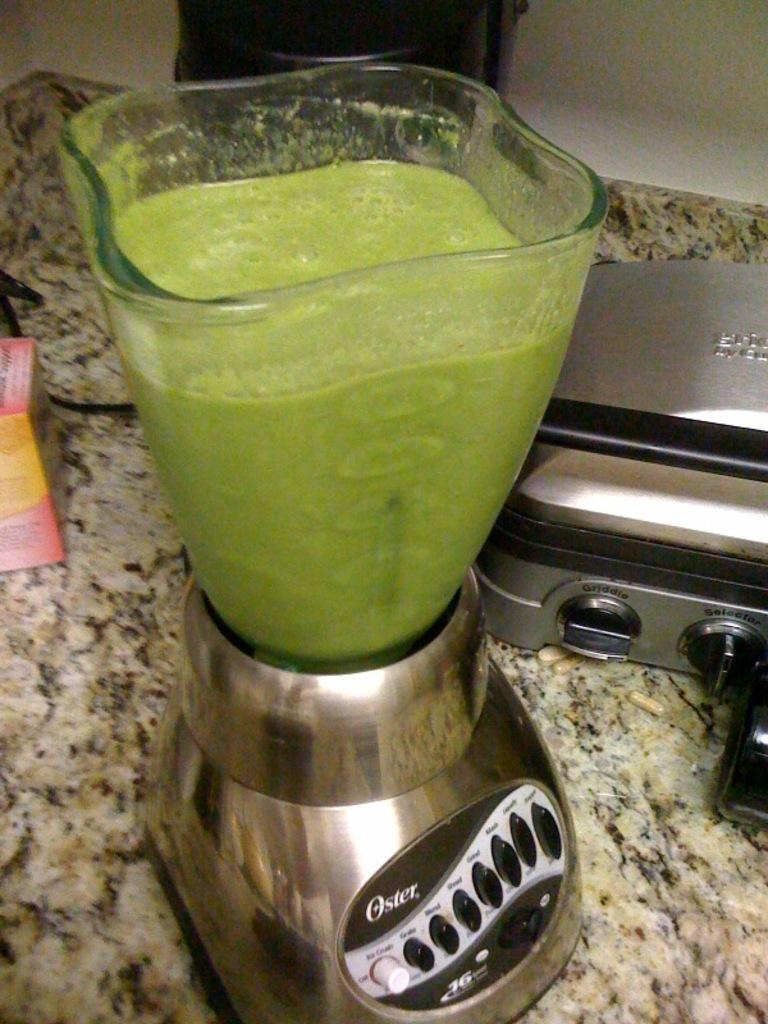<image>
Create a compact narrative representing the image presented. an oster blender, filled with a pale green substance 